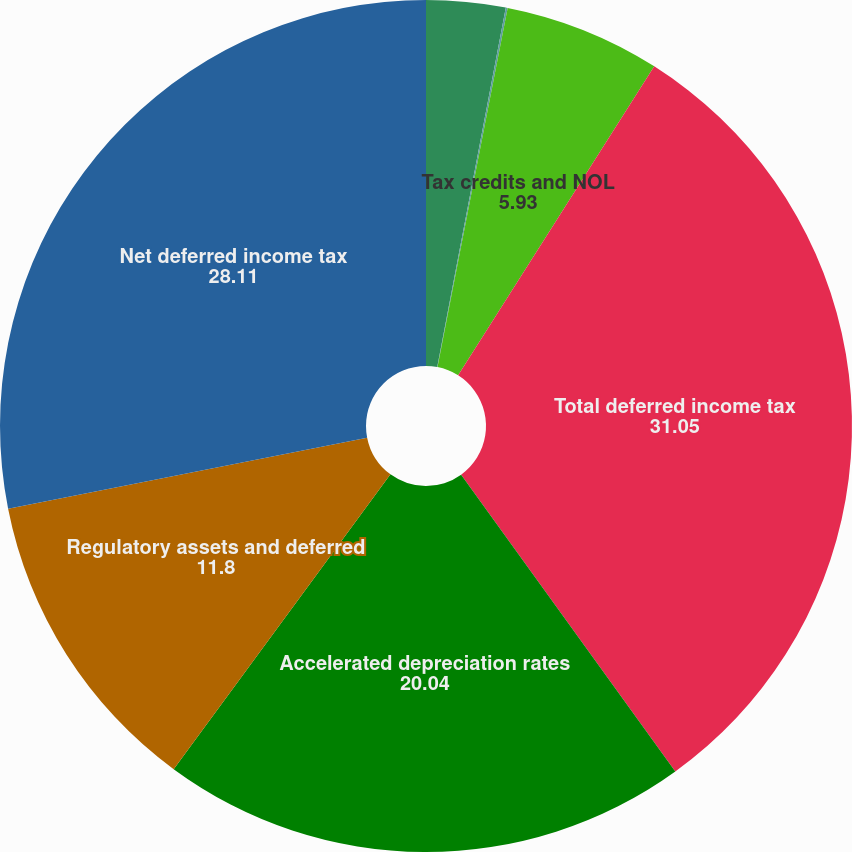Convert chart to OTSL. <chart><loc_0><loc_0><loc_500><loc_500><pie_chart><fcel>Deferred credits and other<fcel>Pension post-retirement and<fcel>Tax credits and NOL<fcel>Total deferred income tax<fcel>Accelerated depreciation rates<fcel>Regulatory assets and deferred<fcel>Net deferred income tax<nl><fcel>3.0%<fcel>0.07%<fcel>5.93%<fcel>31.05%<fcel>20.04%<fcel>11.8%<fcel>28.11%<nl></chart> 